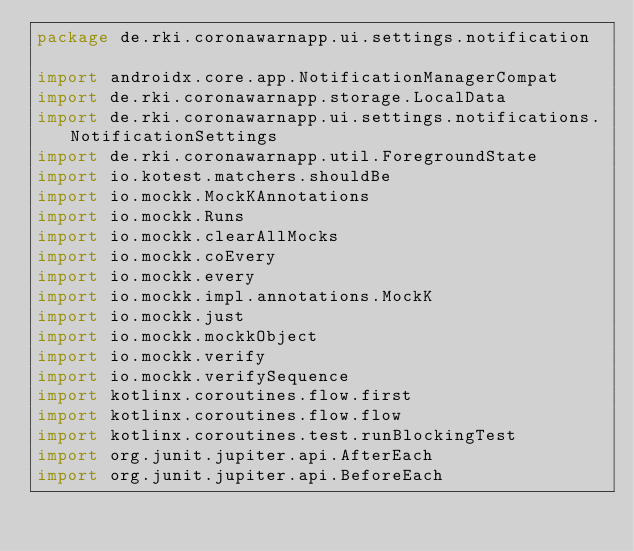<code> <loc_0><loc_0><loc_500><loc_500><_Kotlin_>package de.rki.coronawarnapp.ui.settings.notification

import androidx.core.app.NotificationManagerCompat
import de.rki.coronawarnapp.storage.LocalData
import de.rki.coronawarnapp.ui.settings.notifications.NotificationSettings
import de.rki.coronawarnapp.util.ForegroundState
import io.kotest.matchers.shouldBe
import io.mockk.MockKAnnotations
import io.mockk.Runs
import io.mockk.clearAllMocks
import io.mockk.coEvery
import io.mockk.every
import io.mockk.impl.annotations.MockK
import io.mockk.just
import io.mockk.mockkObject
import io.mockk.verify
import io.mockk.verifySequence
import kotlinx.coroutines.flow.first
import kotlinx.coroutines.flow.flow
import kotlinx.coroutines.test.runBlockingTest
import org.junit.jupiter.api.AfterEach
import org.junit.jupiter.api.BeforeEach</code> 